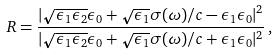Convert formula to latex. <formula><loc_0><loc_0><loc_500><loc_500>R = \frac { | \sqrt { \epsilon _ { 1 } \epsilon _ { 2 } } \epsilon _ { 0 } + \sqrt { \epsilon _ { 1 } } \sigma ( \omega ) / c - \epsilon _ { 1 } \epsilon _ { 0 } | ^ { 2 } } { | \sqrt { \epsilon _ { 1 } \epsilon _ { 2 } } \epsilon _ { 0 } + \sqrt { \epsilon _ { 1 } } \sigma ( \omega ) / c + \epsilon _ { 1 } \epsilon _ { 0 } | ^ { 2 } } \, ,</formula> 